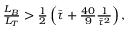<formula> <loc_0><loc_0><loc_500><loc_500>\begin{array} { r } { \frac { L _ { B } } { L _ { T } } > \frac { 1 } { 2 } \left ( \bar { \tau } + \frac { 4 0 } { 9 } \frac { 1 } { \bar { \tau } ^ { 2 } } \right ) , } \end{array}</formula> 